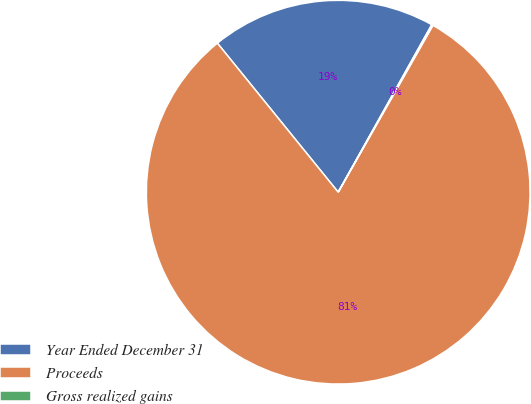<chart> <loc_0><loc_0><loc_500><loc_500><pie_chart><fcel>Year Ended December 31<fcel>Proceeds<fcel>Gross realized gains<nl><fcel>18.95%<fcel>80.94%<fcel>0.11%<nl></chart> 